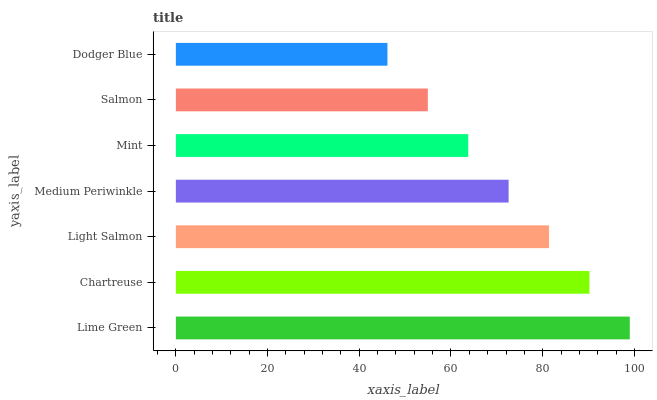Is Dodger Blue the minimum?
Answer yes or no. Yes. Is Lime Green the maximum?
Answer yes or no. Yes. Is Chartreuse the minimum?
Answer yes or no. No. Is Chartreuse the maximum?
Answer yes or no. No. Is Lime Green greater than Chartreuse?
Answer yes or no. Yes. Is Chartreuse less than Lime Green?
Answer yes or no. Yes. Is Chartreuse greater than Lime Green?
Answer yes or no. No. Is Lime Green less than Chartreuse?
Answer yes or no. No. Is Medium Periwinkle the high median?
Answer yes or no. Yes. Is Medium Periwinkle the low median?
Answer yes or no. Yes. Is Salmon the high median?
Answer yes or no. No. Is Mint the low median?
Answer yes or no. No. 